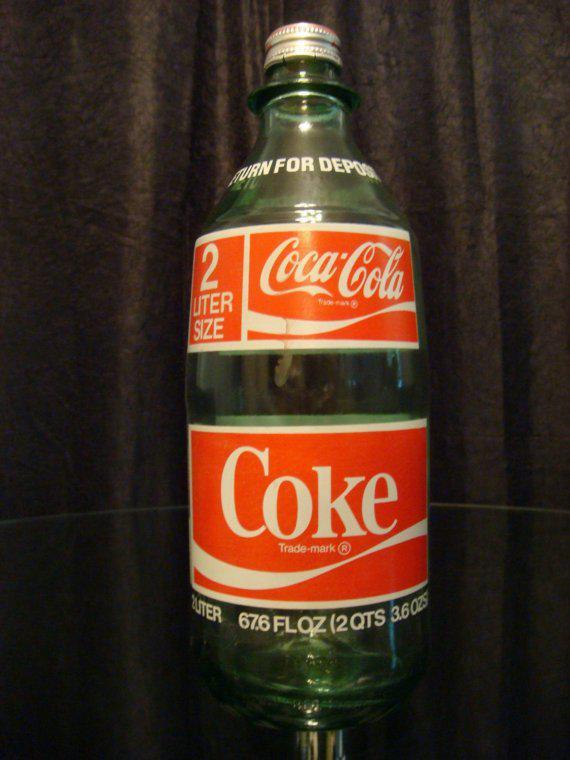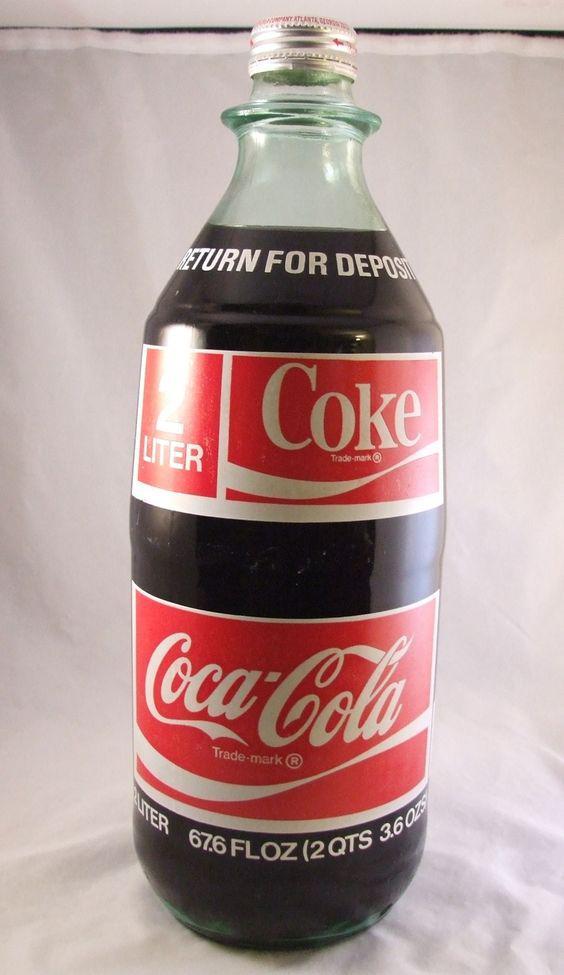The first image is the image on the left, the second image is the image on the right. Examine the images to the left and right. Is the description "There is one bottle in each image." accurate? Answer yes or no. Yes. The first image is the image on the left, the second image is the image on the right. Given the left and right images, does the statement "The bottle in one of the images could be called a jug." hold true? Answer yes or no. No. 